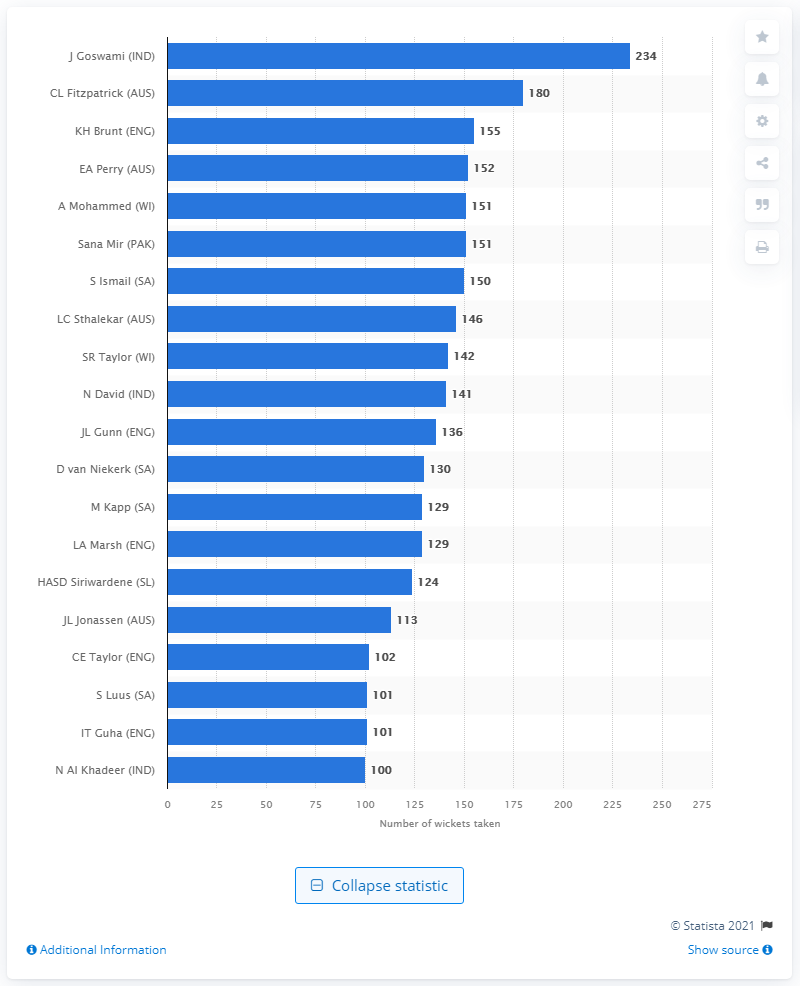Point out several critical features in this image. Goswami took a total of 234 wickets in 187 women's ODIs played between 2002 and 2021. 